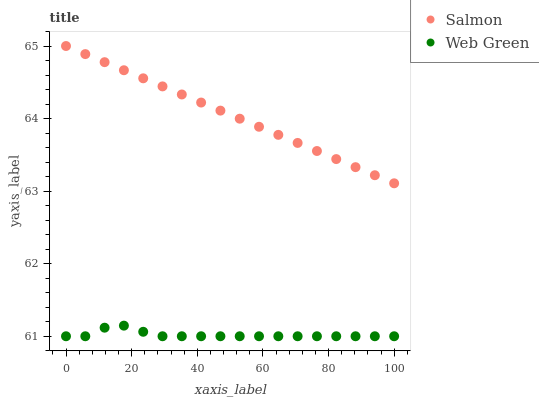Does Web Green have the minimum area under the curve?
Answer yes or no. Yes. Does Salmon have the maximum area under the curve?
Answer yes or no. Yes. Does Web Green have the maximum area under the curve?
Answer yes or no. No. Is Salmon the smoothest?
Answer yes or no. Yes. Is Web Green the roughest?
Answer yes or no. Yes. Is Web Green the smoothest?
Answer yes or no. No. Does Web Green have the lowest value?
Answer yes or no. Yes. Does Salmon have the highest value?
Answer yes or no. Yes. Does Web Green have the highest value?
Answer yes or no. No. Is Web Green less than Salmon?
Answer yes or no. Yes. Is Salmon greater than Web Green?
Answer yes or no. Yes. Does Web Green intersect Salmon?
Answer yes or no. No. 